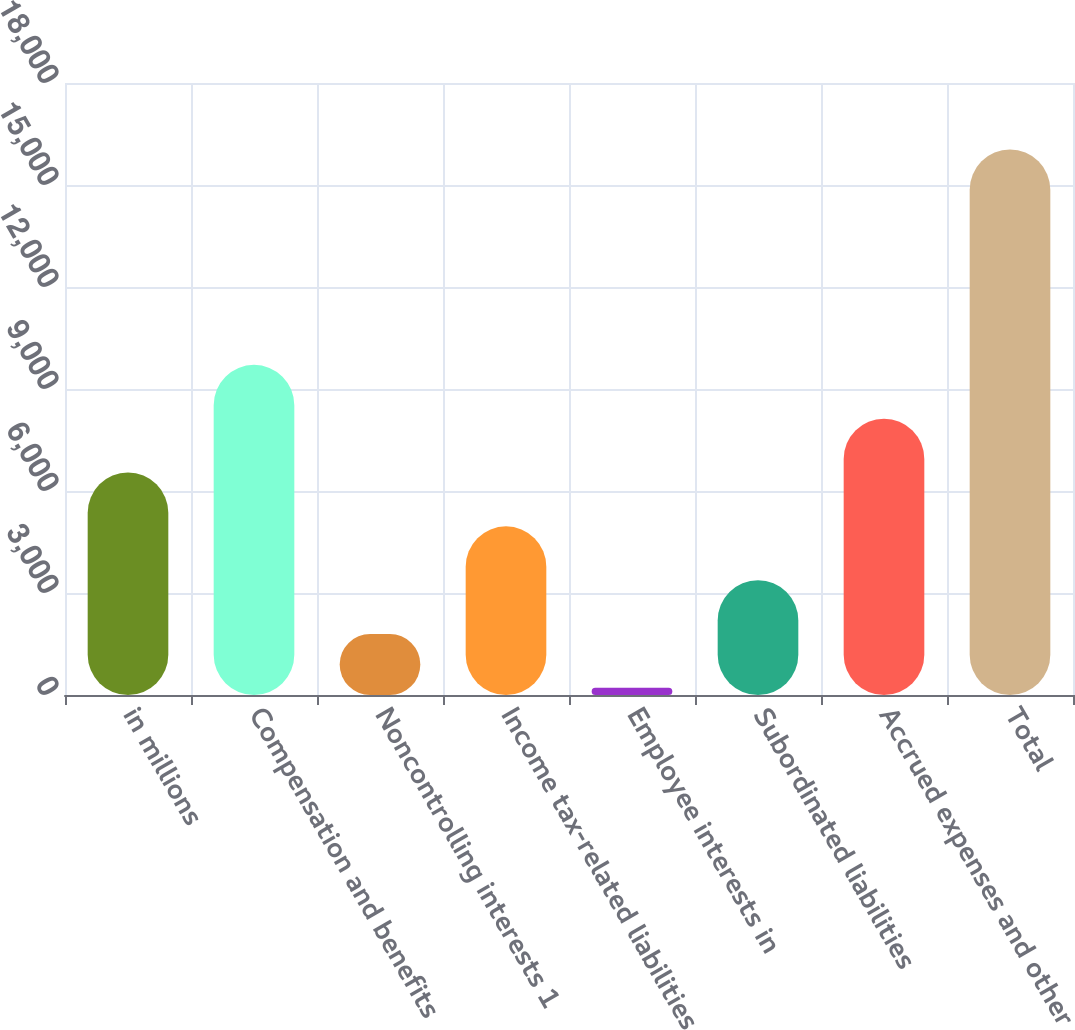Convert chart. <chart><loc_0><loc_0><loc_500><loc_500><bar_chart><fcel>in millions<fcel>Compensation and benefits<fcel>Noncontrolling interests 1<fcel>Income tax-related liabilities<fcel>Employee interests in<fcel>Subordinated liabilities<fcel>Accrued expenses and other<fcel>Total<nl><fcel>6543.6<fcel>9710.4<fcel>1793.4<fcel>4960.2<fcel>210<fcel>3376.8<fcel>8127<fcel>16044<nl></chart> 